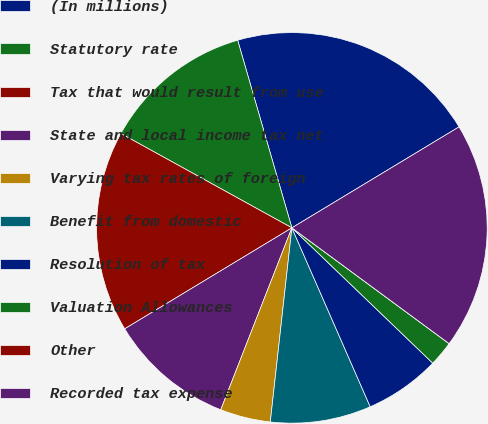Convert chart. <chart><loc_0><loc_0><loc_500><loc_500><pie_chart><fcel>(In millions)<fcel>Statutory rate<fcel>Tax that would result from use<fcel>State and local income tax net<fcel>Varying tax rates of foreign<fcel>Benefit from domestic<fcel>Resolution of tax<fcel>Valuation Allowances<fcel>Other<fcel>Recorded tax expense<nl><fcel>20.83%<fcel>12.5%<fcel>16.67%<fcel>10.42%<fcel>4.17%<fcel>8.33%<fcel>6.25%<fcel>2.08%<fcel>0.0%<fcel>18.75%<nl></chart> 